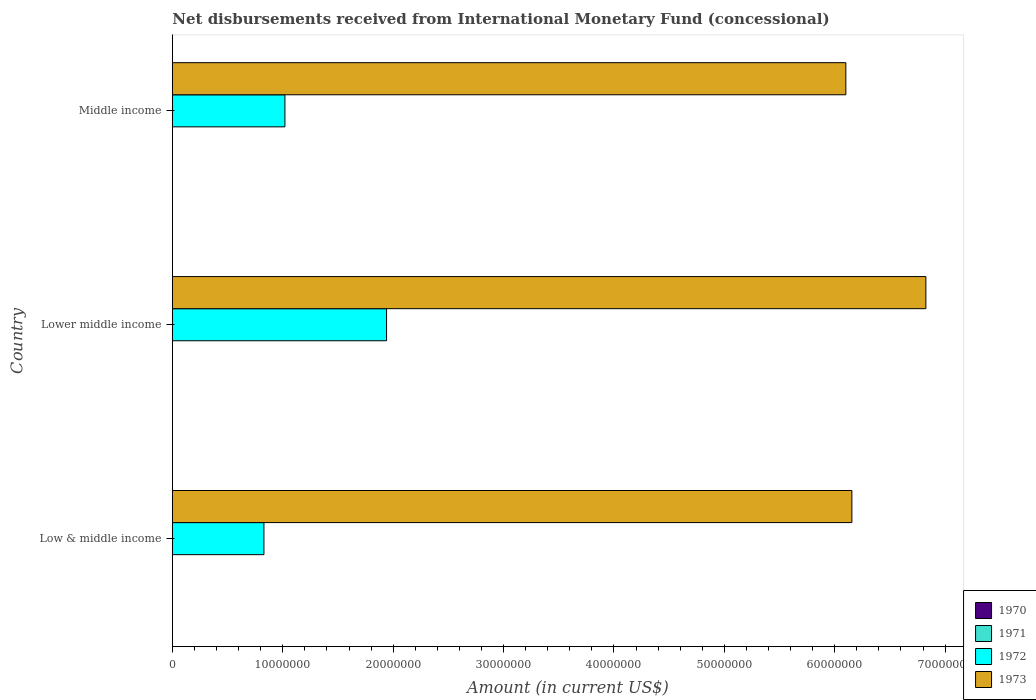How many different coloured bars are there?
Your answer should be very brief. 2. In how many cases, is the number of bars for a given country not equal to the number of legend labels?
Offer a very short reply. 3. What is the amount of disbursements received from International Monetary Fund in 1973 in Lower middle income?
Make the answer very short. 6.83e+07. Across all countries, what is the maximum amount of disbursements received from International Monetary Fund in 1973?
Provide a succinct answer. 6.83e+07. In which country was the amount of disbursements received from International Monetary Fund in 1973 maximum?
Your answer should be very brief. Lower middle income. What is the total amount of disbursements received from International Monetary Fund in 1972 in the graph?
Your answer should be compact. 3.79e+07. What is the difference between the amount of disbursements received from International Monetary Fund in 1973 in Lower middle income and that in Middle income?
Ensure brevity in your answer.  7.25e+06. What is the difference between the amount of disbursements received from International Monetary Fund in 1973 in Lower middle income and the amount of disbursements received from International Monetary Fund in 1972 in Low & middle income?
Provide a succinct answer. 6.00e+07. What is the average amount of disbursements received from International Monetary Fund in 1972 per country?
Keep it short and to the point. 1.26e+07. What is the difference between the amount of disbursements received from International Monetary Fund in 1972 and amount of disbursements received from International Monetary Fund in 1973 in Low & middle income?
Your answer should be compact. -5.33e+07. What is the difference between the highest and the second highest amount of disbursements received from International Monetary Fund in 1973?
Ensure brevity in your answer.  6.70e+06. What is the difference between the highest and the lowest amount of disbursements received from International Monetary Fund in 1973?
Ensure brevity in your answer.  7.25e+06. In how many countries, is the amount of disbursements received from International Monetary Fund in 1972 greater than the average amount of disbursements received from International Monetary Fund in 1972 taken over all countries?
Your answer should be compact. 1. Is the sum of the amount of disbursements received from International Monetary Fund in 1973 in Low & middle income and Lower middle income greater than the maximum amount of disbursements received from International Monetary Fund in 1972 across all countries?
Ensure brevity in your answer.  Yes. Is it the case that in every country, the sum of the amount of disbursements received from International Monetary Fund in 1973 and amount of disbursements received from International Monetary Fund in 1970 is greater than the sum of amount of disbursements received from International Monetary Fund in 1971 and amount of disbursements received from International Monetary Fund in 1972?
Provide a succinct answer. No. What is the difference between two consecutive major ticks on the X-axis?
Provide a succinct answer. 1.00e+07. Does the graph contain any zero values?
Offer a terse response. Yes. Does the graph contain grids?
Your answer should be very brief. No. What is the title of the graph?
Offer a terse response. Net disbursements received from International Monetary Fund (concessional). Does "1962" appear as one of the legend labels in the graph?
Make the answer very short. No. What is the label or title of the Y-axis?
Offer a terse response. Country. What is the Amount (in current US$) of 1970 in Low & middle income?
Offer a terse response. 0. What is the Amount (in current US$) of 1971 in Low & middle income?
Make the answer very short. 0. What is the Amount (in current US$) of 1972 in Low & middle income?
Ensure brevity in your answer.  8.30e+06. What is the Amount (in current US$) in 1973 in Low & middle income?
Give a very brief answer. 6.16e+07. What is the Amount (in current US$) in 1970 in Lower middle income?
Provide a short and direct response. 0. What is the Amount (in current US$) in 1972 in Lower middle income?
Ensure brevity in your answer.  1.94e+07. What is the Amount (in current US$) in 1973 in Lower middle income?
Give a very brief answer. 6.83e+07. What is the Amount (in current US$) in 1972 in Middle income?
Make the answer very short. 1.02e+07. What is the Amount (in current US$) of 1973 in Middle income?
Provide a succinct answer. 6.10e+07. Across all countries, what is the maximum Amount (in current US$) in 1972?
Your answer should be very brief. 1.94e+07. Across all countries, what is the maximum Amount (in current US$) in 1973?
Your answer should be compact. 6.83e+07. Across all countries, what is the minimum Amount (in current US$) of 1972?
Provide a succinct answer. 8.30e+06. Across all countries, what is the minimum Amount (in current US$) of 1973?
Your response must be concise. 6.10e+07. What is the total Amount (in current US$) in 1970 in the graph?
Your answer should be very brief. 0. What is the total Amount (in current US$) of 1972 in the graph?
Offer a terse response. 3.79e+07. What is the total Amount (in current US$) in 1973 in the graph?
Provide a succinct answer. 1.91e+08. What is the difference between the Amount (in current US$) in 1972 in Low & middle income and that in Lower middle income?
Your answer should be compact. -1.11e+07. What is the difference between the Amount (in current US$) in 1973 in Low & middle income and that in Lower middle income?
Keep it short and to the point. -6.70e+06. What is the difference between the Amount (in current US$) of 1972 in Low & middle income and that in Middle income?
Make the answer very short. -1.90e+06. What is the difference between the Amount (in current US$) of 1973 in Low & middle income and that in Middle income?
Your answer should be very brief. 5.46e+05. What is the difference between the Amount (in current US$) of 1972 in Lower middle income and that in Middle income?
Keep it short and to the point. 9.21e+06. What is the difference between the Amount (in current US$) in 1973 in Lower middle income and that in Middle income?
Ensure brevity in your answer.  7.25e+06. What is the difference between the Amount (in current US$) in 1972 in Low & middle income and the Amount (in current US$) in 1973 in Lower middle income?
Ensure brevity in your answer.  -6.00e+07. What is the difference between the Amount (in current US$) of 1972 in Low & middle income and the Amount (in current US$) of 1973 in Middle income?
Your response must be concise. -5.27e+07. What is the difference between the Amount (in current US$) in 1972 in Lower middle income and the Amount (in current US$) in 1973 in Middle income?
Make the answer very short. -4.16e+07. What is the average Amount (in current US$) of 1970 per country?
Provide a short and direct response. 0. What is the average Amount (in current US$) in 1971 per country?
Ensure brevity in your answer.  0. What is the average Amount (in current US$) of 1972 per country?
Offer a terse response. 1.26e+07. What is the average Amount (in current US$) of 1973 per country?
Keep it short and to the point. 6.36e+07. What is the difference between the Amount (in current US$) in 1972 and Amount (in current US$) in 1973 in Low & middle income?
Provide a short and direct response. -5.33e+07. What is the difference between the Amount (in current US$) in 1972 and Amount (in current US$) in 1973 in Lower middle income?
Keep it short and to the point. -4.89e+07. What is the difference between the Amount (in current US$) in 1972 and Amount (in current US$) in 1973 in Middle income?
Make the answer very short. -5.08e+07. What is the ratio of the Amount (in current US$) in 1972 in Low & middle income to that in Lower middle income?
Your response must be concise. 0.43. What is the ratio of the Amount (in current US$) in 1973 in Low & middle income to that in Lower middle income?
Your response must be concise. 0.9. What is the ratio of the Amount (in current US$) of 1972 in Low & middle income to that in Middle income?
Offer a very short reply. 0.81. What is the ratio of the Amount (in current US$) of 1973 in Low & middle income to that in Middle income?
Provide a succinct answer. 1.01. What is the ratio of the Amount (in current US$) of 1972 in Lower middle income to that in Middle income?
Keep it short and to the point. 1.9. What is the ratio of the Amount (in current US$) of 1973 in Lower middle income to that in Middle income?
Your answer should be very brief. 1.12. What is the difference between the highest and the second highest Amount (in current US$) of 1972?
Your answer should be very brief. 9.21e+06. What is the difference between the highest and the second highest Amount (in current US$) in 1973?
Provide a succinct answer. 6.70e+06. What is the difference between the highest and the lowest Amount (in current US$) in 1972?
Keep it short and to the point. 1.11e+07. What is the difference between the highest and the lowest Amount (in current US$) in 1973?
Ensure brevity in your answer.  7.25e+06. 